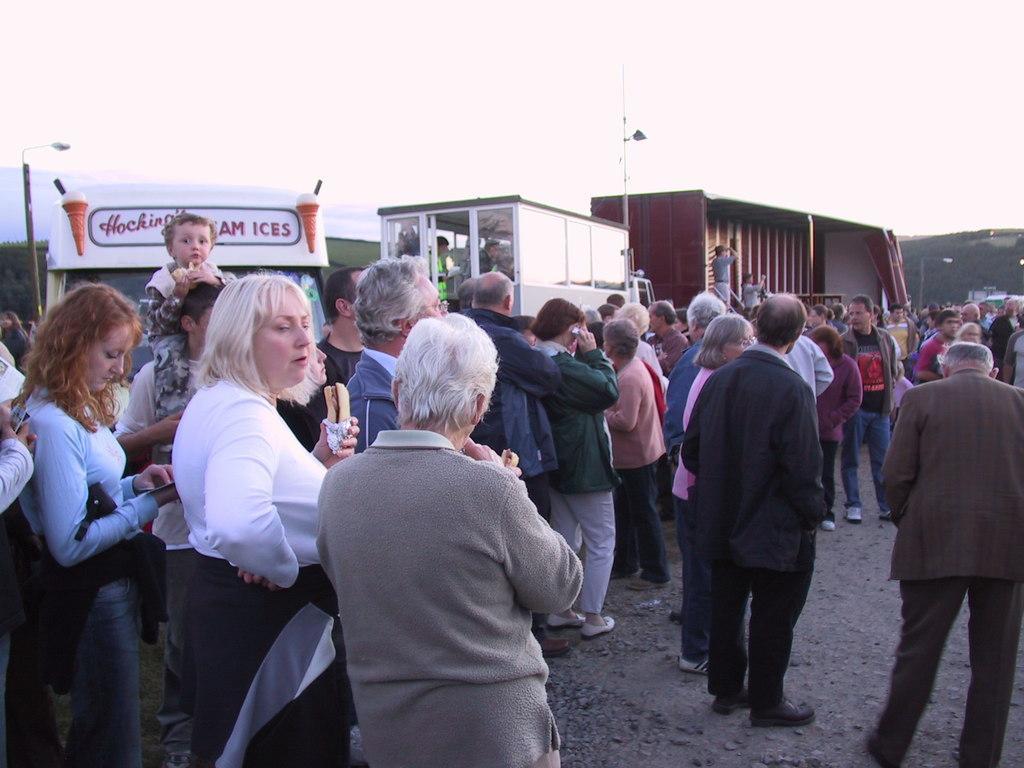Please provide a concise description of this image. In the image we can see there are many people standing, they are wearing clothes and shoes. This is a footpath, vehicle, light pole, mountain and a white sky. This person is holding a food item in hand. 